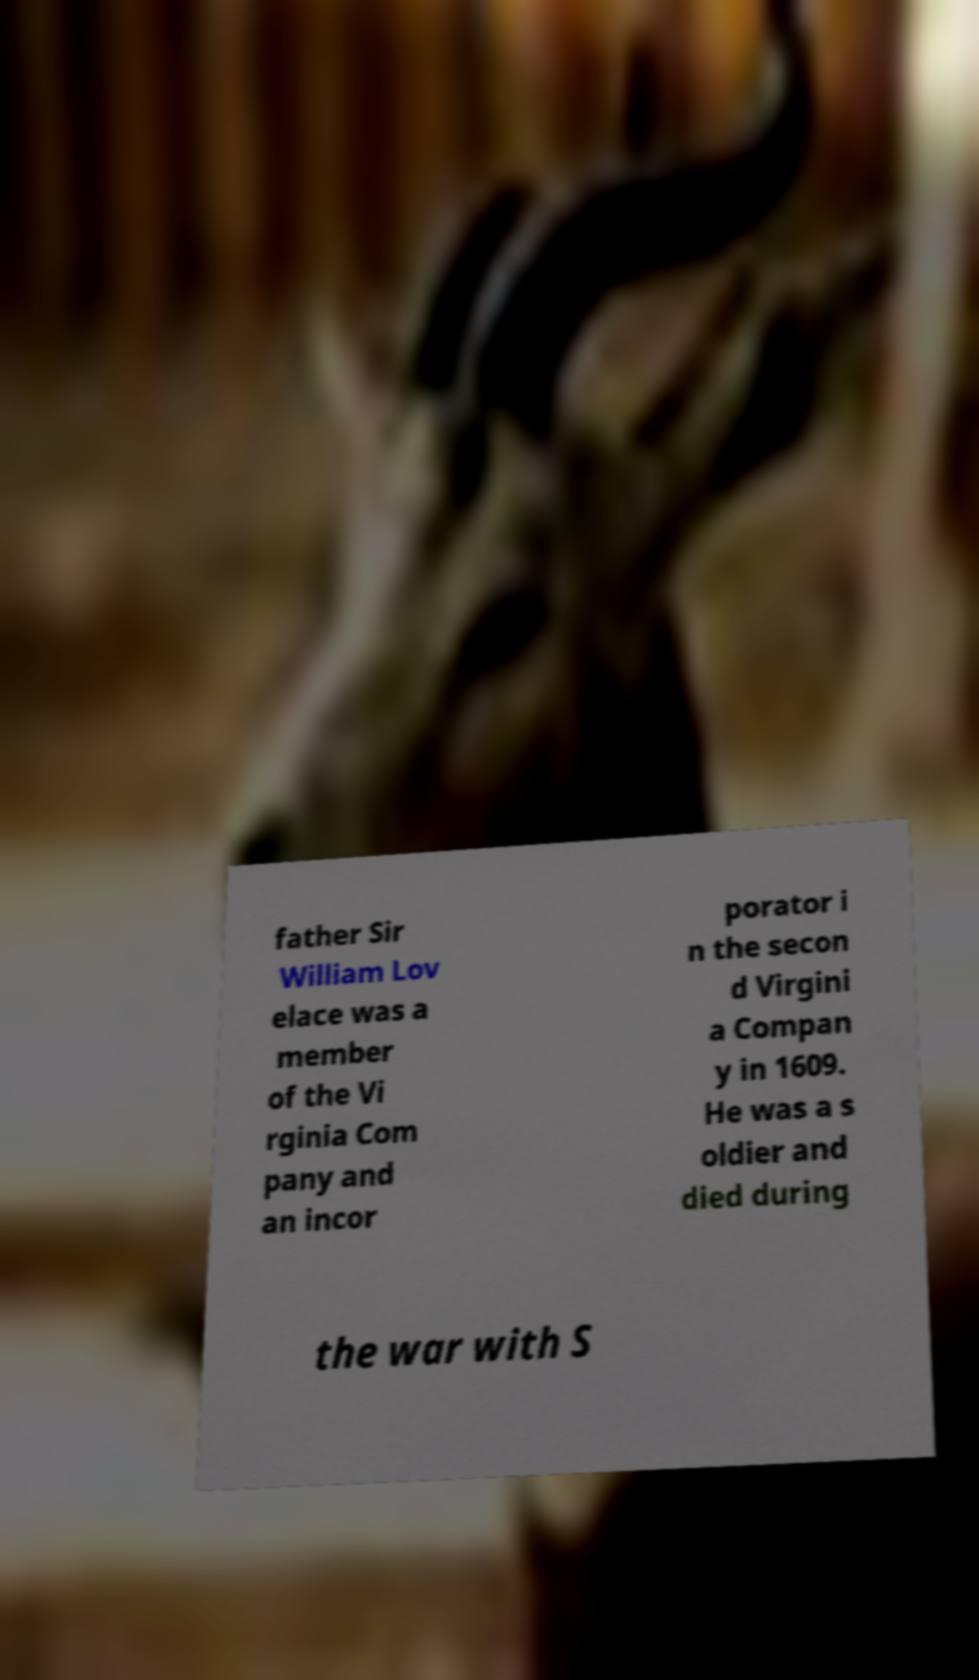Please read and relay the text visible in this image. What does it say? father Sir William Lov elace was a member of the Vi rginia Com pany and an incor porator i n the secon d Virgini a Compan y in 1609. He was a s oldier and died during the war with S 